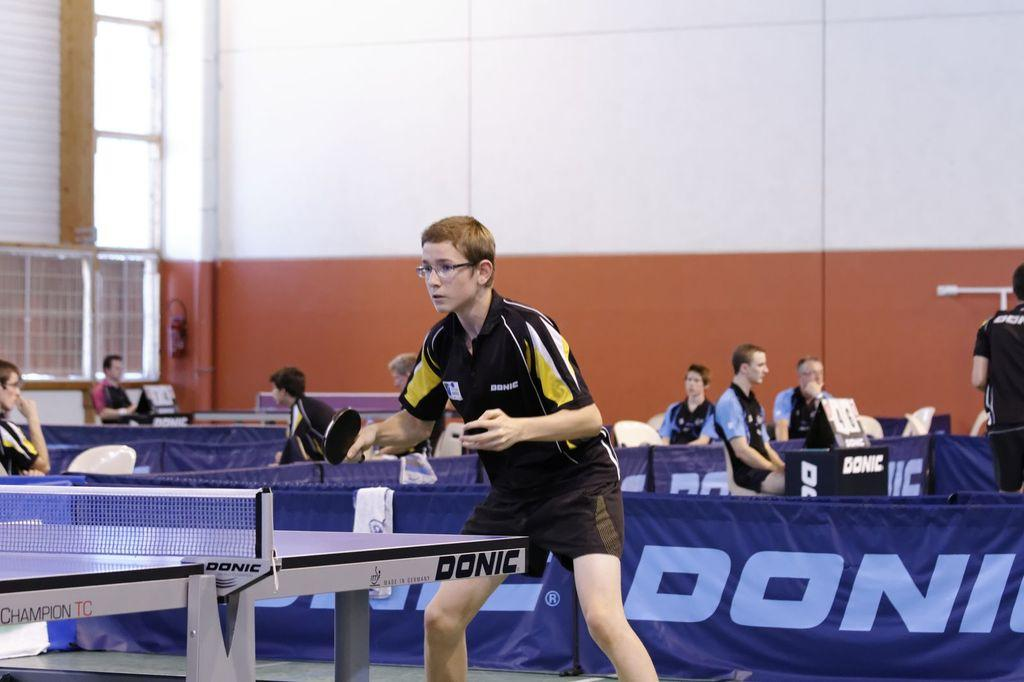What activity is the person in the image engaged in? There is a person playing table tennis in the image. Can you describe the other people visible in the image? Unfortunately, the facts provided do not give any details about the other people in the image. What type of vacation is the person planning based on the image? There is no information about a vacation in the image, as it only shows a person playing table tennis and other people. How does the brain of the person playing table tennis look in the image? There is no information about the person's brain in the image, as it only shows them playing table tennis and other people. 